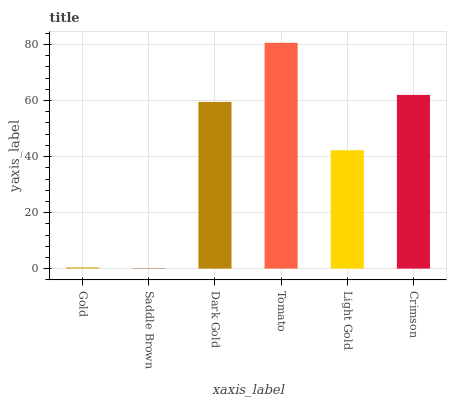Is Saddle Brown the minimum?
Answer yes or no. Yes. Is Tomato the maximum?
Answer yes or no. Yes. Is Dark Gold the minimum?
Answer yes or no. No. Is Dark Gold the maximum?
Answer yes or no. No. Is Dark Gold greater than Saddle Brown?
Answer yes or no. Yes. Is Saddle Brown less than Dark Gold?
Answer yes or no. Yes. Is Saddle Brown greater than Dark Gold?
Answer yes or no. No. Is Dark Gold less than Saddle Brown?
Answer yes or no. No. Is Dark Gold the high median?
Answer yes or no. Yes. Is Light Gold the low median?
Answer yes or no. Yes. Is Gold the high median?
Answer yes or no. No. Is Tomato the low median?
Answer yes or no. No. 